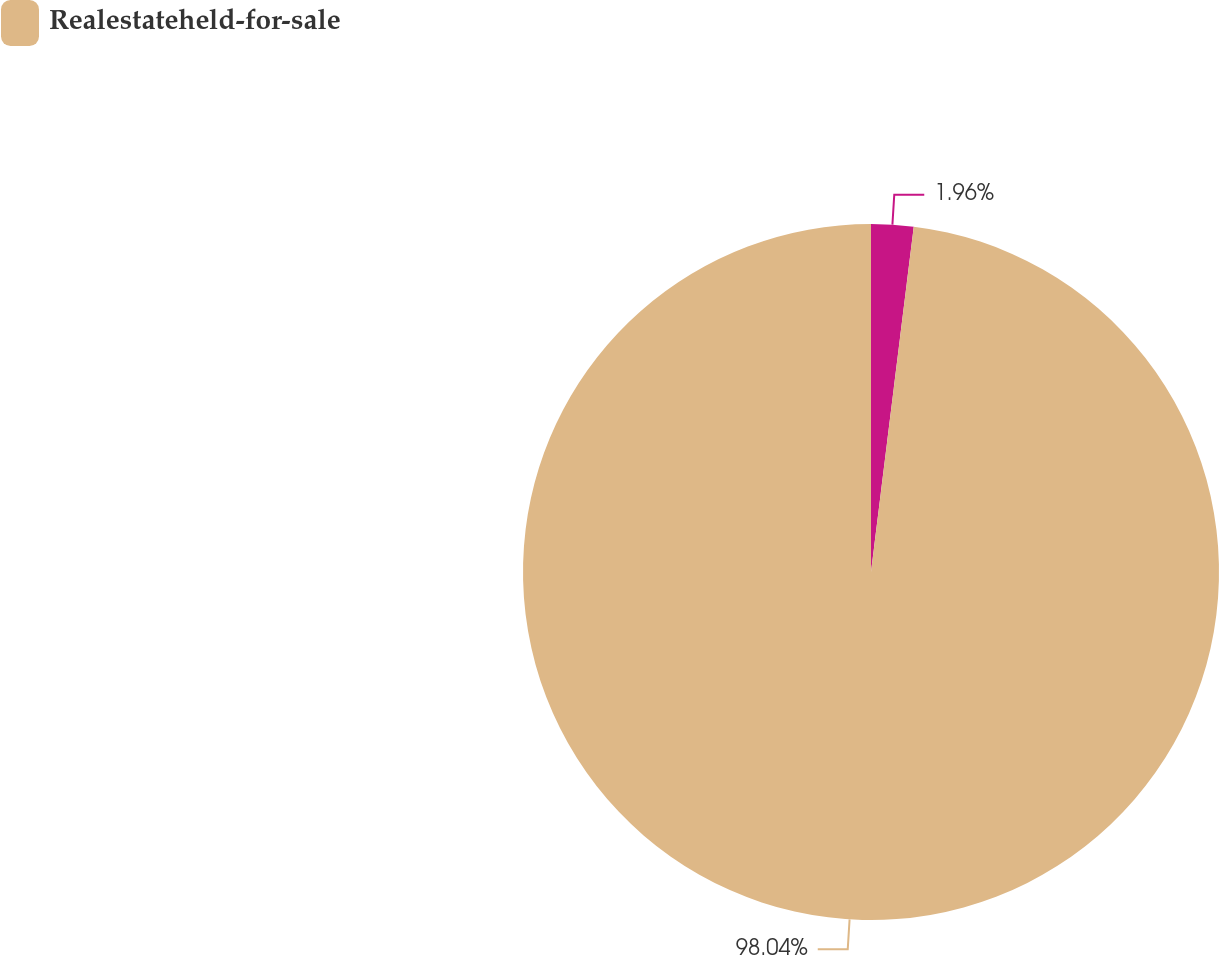Convert chart to OTSL. <chart><loc_0><loc_0><loc_500><loc_500><pie_chart><ecel><fcel>Realestateheld-for-sale<nl><fcel>1.96%<fcel>98.04%<nl></chart> 